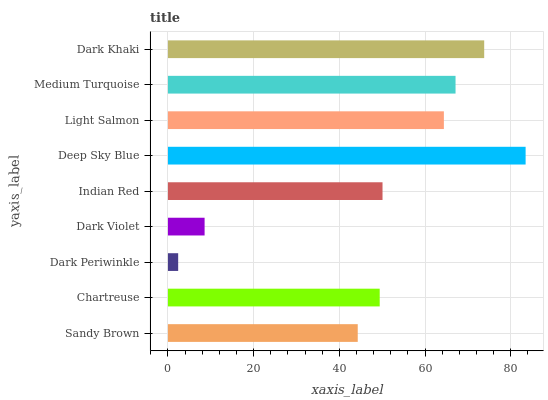Is Dark Periwinkle the minimum?
Answer yes or no. Yes. Is Deep Sky Blue the maximum?
Answer yes or no. Yes. Is Chartreuse the minimum?
Answer yes or no. No. Is Chartreuse the maximum?
Answer yes or no. No. Is Chartreuse greater than Sandy Brown?
Answer yes or no. Yes. Is Sandy Brown less than Chartreuse?
Answer yes or no. Yes. Is Sandy Brown greater than Chartreuse?
Answer yes or no. No. Is Chartreuse less than Sandy Brown?
Answer yes or no. No. Is Indian Red the high median?
Answer yes or no. Yes. Is Indian Red the low median?
Answer yes or no. Yes. Is Medium Turquoise the high median?
Answer yes or no. No. Is Dark Violet the low median?
Answer yes or no. No. 